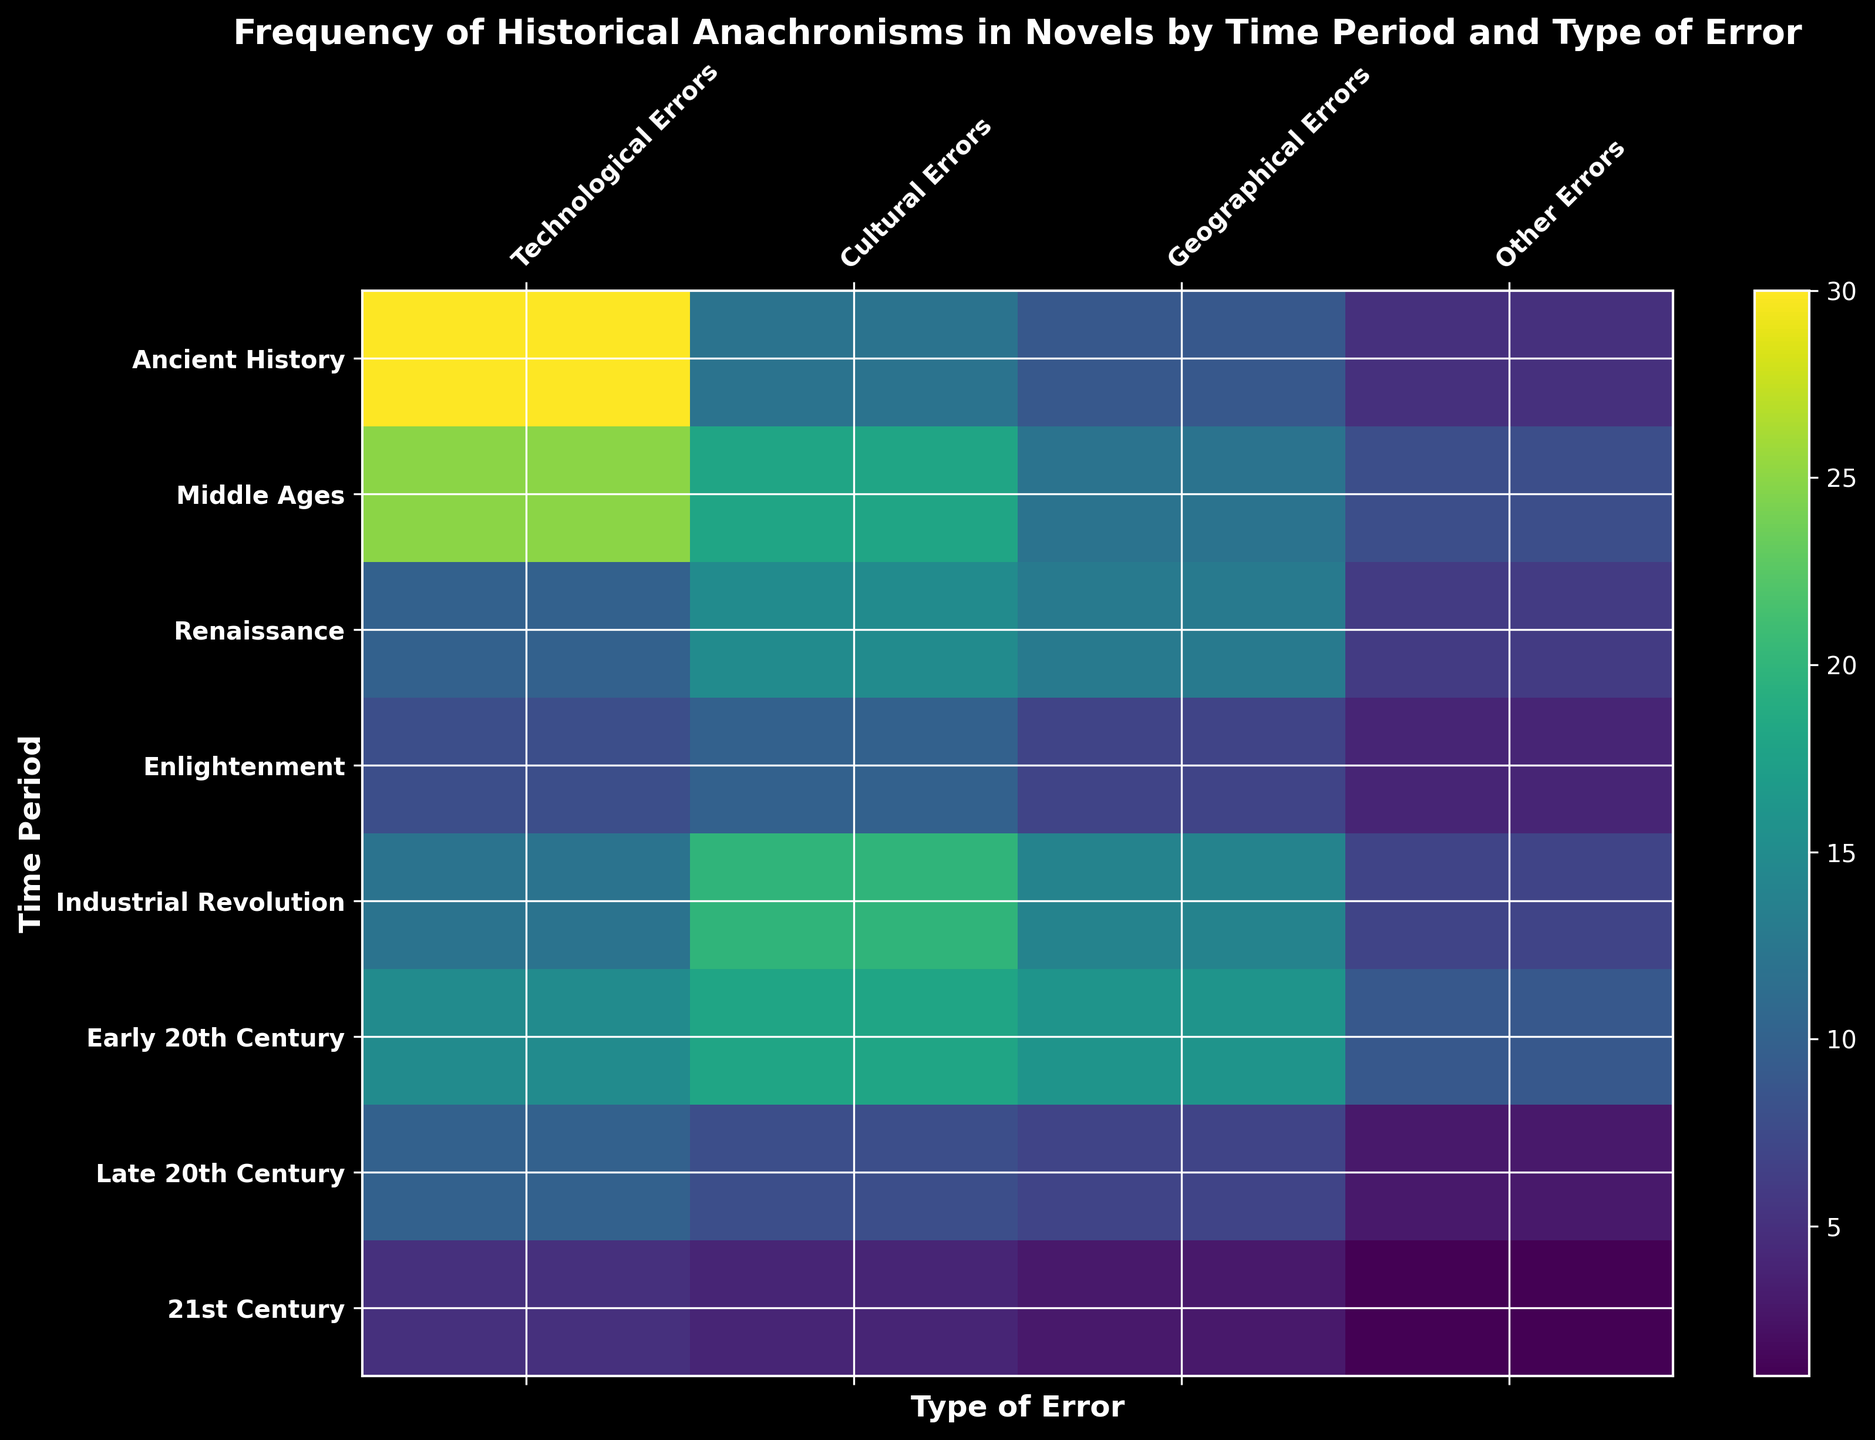Which time period has the most technological errors? By visually inspecting the height of the colored bar in the row for each time period under the 'Technological Errors' column, it's evident that 'Ancient History' has the highest frequency of technological errors.
Answer: Ancient History Comparing the Middle Ages and Renaissance, which has more total errors? Calculate the total errors for each period: Middle Ages has 25 (Technological) + 18 (Cultural) + 12 (Geographical) + 8 (Other) = 63. Renaissance has 10 (Technological) + 15 (Cultural) + 13 (Geographical) + 6 (Other) = 44. Comparing 63 and 44, Middle Ages has more errors.
Answer: Middle Ages Regarding geographical errors, which time period has the lowest count? By examining the 'Geographical Errors' column, the smallest value corresponding to the '21st Century' indicates it has the lowest count of geographical errors.
Answer: 21st Century Which type of error is most frequent in the Early 20th Century? Analyzing the different columns for the 'Early 20th Century', the value with the highest frequency is 16 in 'Geographical Errors'.
Answer: Geographical Errors How many more cultural errors are there in the Industrial Revolution than in the Enlightenment period? Industrial Revolution has 20 Cultural Errors, Enlightenment has 10. The difference is 20 - 10 = 10.
Answer: 10 What is the average number of other errors in the periods Enlightenment and Renaissance? Enlightenment has 4 and Renaissance has 6, the average is (4 + 6) / 2 = 5.
Answer: 5 In which time period do cultural errors peak? Checking the 'Cultural Errors' column, the Industrial Revolution has the highest frequency with 20 cultural errors.
Answer: Industrial Revolution How does the total number of errors in the 21st Century compare to that in the Ancient History period? Summing up the errors: 21st Century has 5 (Technological) + 4 (Cultural) + 3 (Geographical) + 1 (Other) = 13. Ancient History has 30 (Technological) + 12 (Cultural) + 9 (Geographical) + 5 (Other) = 56. Comparing 13 with 56, 21st Century has fewer total errors.
Answer: 21st Century Which column represents errors that are visually greenish-yellow in Ancient History compared to darker colors in the Enlightenment? Observing the visual attributes of the heatmap for 'Ancient History', 'Technological Errors' appears bright or greenish-yellow whereas in 'Enlightenment', it appears darker.
Answer: Technological Errors What is the ratio of technological errors in the Industrial Revolution to those in the Middle Ages? Industrial Revolution has 12 Technological Errors, Middle Ages has 25. The ratio is 12:25 or 12/25.
Answer: 12/25 